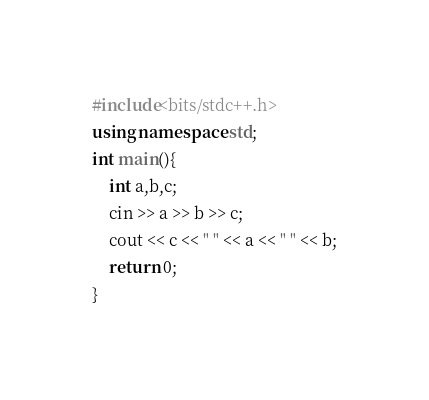Convert code to text. <code><loc_0><loc_0><loc_500><loc_500><_C++_>#include<bits/stdc++.h>
using namespace std;
int main(){
    int a,b,c;
    cin >> a >> b >> c;
    cout << c << " " << a << " " << b;
    return 0;
}</code> 